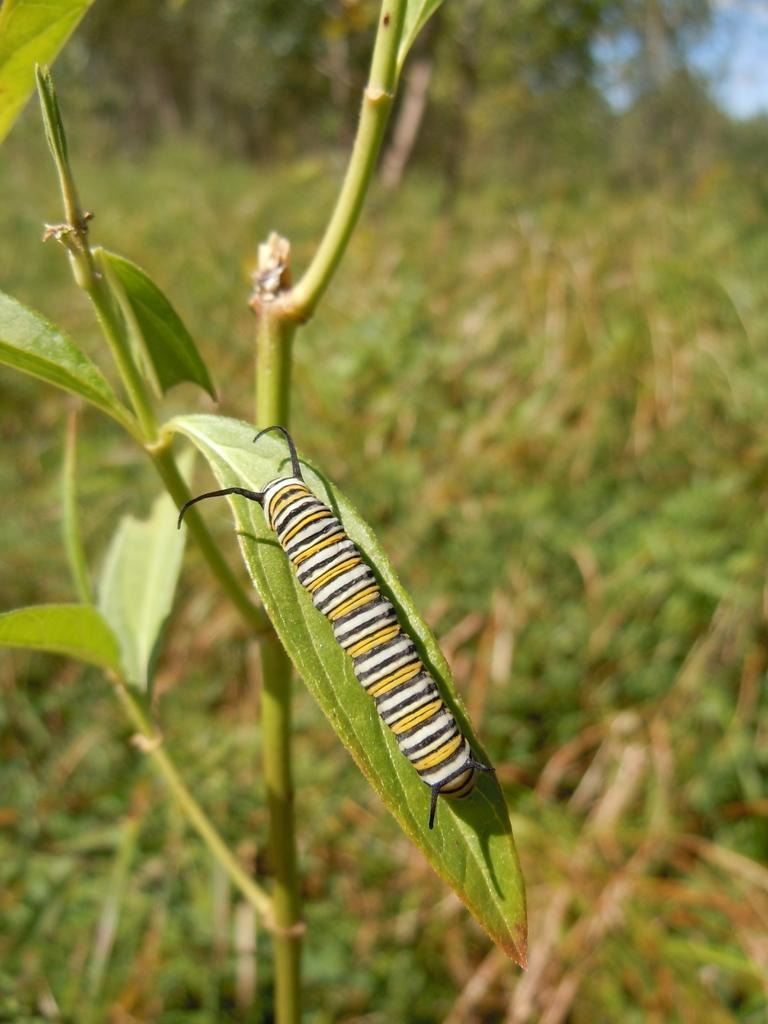What type of insect is on a leaf in the image? There is a caterpillar on a leaf in the image. What type of plant is visible in the image? There is a plant in the image. What other vegetation can be seen in the image? There are bushes in the image. What type of cord is being used to hold up the gate in the image? There is no gate or cord present in the image; it features a caterpillar on a leaf and plants. What color is the sock on the caterpillar's foot in the image? There is no sock present on the caterpillar in the image, as caterpillars do not wear socks. 